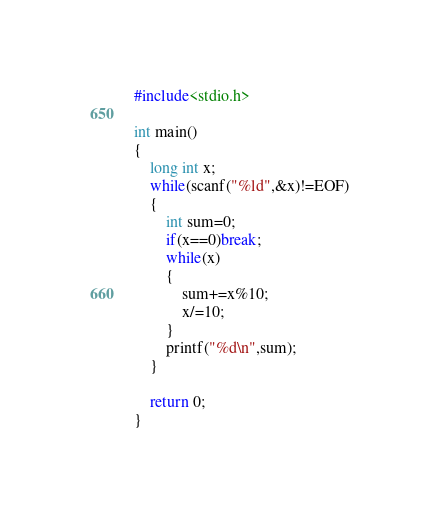<code> <loc_0><loc_0><loc_500><loc_500><_C_>#include<stdio.h>

int main()
{
	long int x;
	while(scanf("%ld",&x)!=EOF)
	{
		int sum=0;
		if(x==0)break;
		while(x)
		{
			sum+=x%10;
			x/=10;
		}
		printf("%d\n",sum);
	}

	return 0;
}</code> 